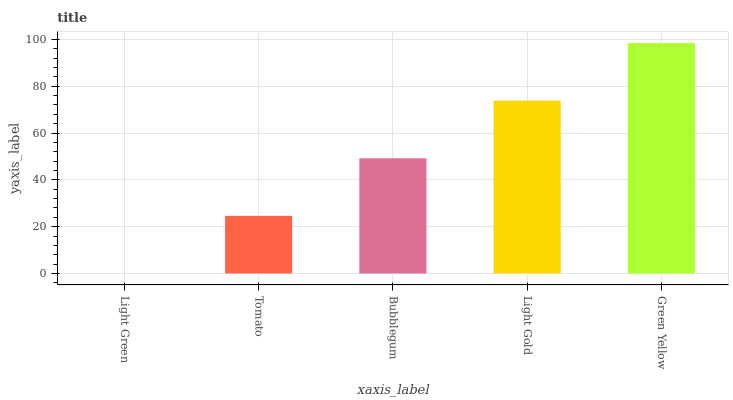Is Light Green the minimum?
Answer yes or no. Yes. Is Green Yellow the maximum?
Answer yes or no. Yes. Is Tomato the minimum?
Answer yes or no. No. Is Tomato the maximum?
Answer yes or no. No. Is Tomato greater than Light Green?
Answer yes or no. Yes. Is Light Green less than Tomato?
Answer yes or no. Yes. Is Light Green greater than Tomato?
Answer yes or no. No. Is Tomato less than Light Green?
Answer yes or no. No. Is Bubblegum the high median?
Answer yes or no. Yes. Is Bubblegum the low median?
Answer yes or no. Yes. Is Light Green the high median?
Answer yes or no. No. Is Tomato the low median?
Answer yes or no. No. 